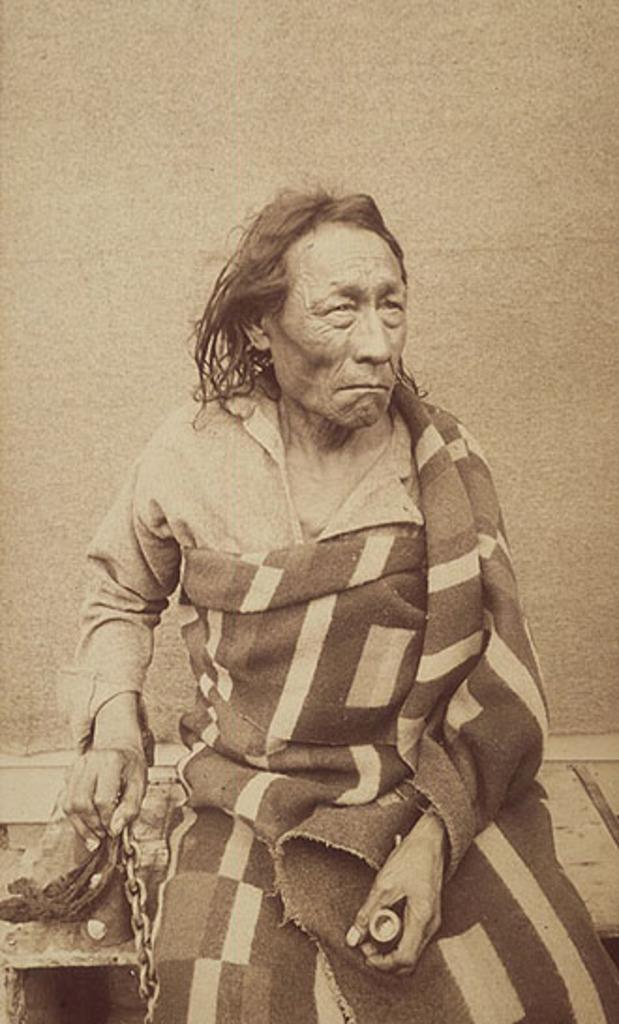What is the person in the image sitting on? The person is sitting on a wooden bench in the image. What is the person holding in their hand? The person is holding a chain in the image. What can be seen in the background of the image? There is a wall in the background of the image. How many ladybugs are crawling on the person's head in the image? There are no ladybugs present in the image. What type of wrench is the person using to fix the wooden bench in the image? There is no wrench visible in the image, and the person is not shown fixing the bench. 